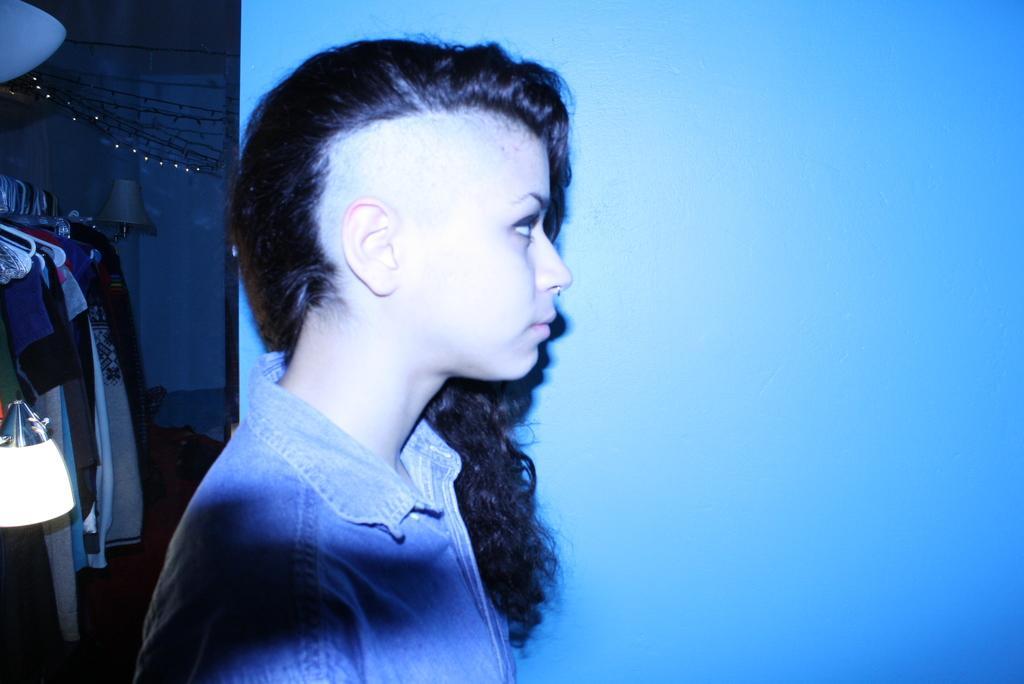Describe this image in one or two sentences. This is the woman standing. On the left side of the image, I can see the clothes hanging to the hangers. This looks like a lamp. I think this is the wall. 